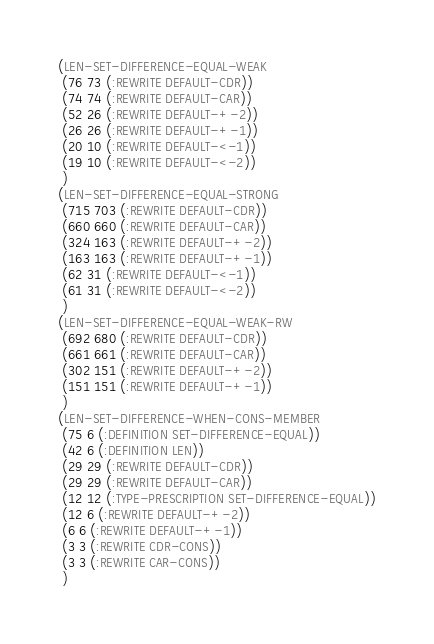<code> <loc_0><loc_0><loc_500><loc_500><_Lisp_>(LEN-SET-DIFFERENCE-EQUAL-WEAK
 (76 73 (:REWRITE DEFAULT-CDR))
 (74 74 (:REWRITE DEFAULT-CAR))
 (52 26 (:REWRITE DEFAULT-+-2))
 (26 26 (:REWRITE DEFAULT-+-1))
 (20 10 (:REWRITE DEFAULT-<-1))
 (19 10 (:REWRITE DEFAULT-<-2))
 )
(LEN-SET-DIFFERENCE-EQUAL-STRONG
 (715 703 (:REWRITE DEFAULT-CDR))
 (660 660 (:REWRITE DEFAULT-CAR))
 (324 163 (:REWRITE DEFAULT-+-2))
 (163 163 (:REWRITE DEFAULT-+-1))
 (62 31 (:REWRITE DEFAULT-<-1))
 (61 31 (:REWRITE DEFAULT-<-2))
 )
(LEN-SET-DIFFERENCE-EQUAL-WEAK-RW
 (692 680 (:REWRITE DEFAULT-CDR))
 (661 661 (:REWRITE DEFAULT-CAR))
 (302 151 (:REWRITE DEFAULT-+-2))
 (151 151 (:REWRITE DEFAULT-+-1))
 )
(LEN-SET-DIFFERENCE-WHEN-CONS-MEMBER
 (75 6 (:DEFINITION SET-DIFFERENCE-EQUAL))
 (42 6 (:DEFINITION LEN))
 (29 29 (:REWRITE DEFAULT-CDR))
 (29 29 (:REWRITE DEFAULT-CAR))
 (12 12 (:TYPE-PRESCRIPTION SET-DIFFERENCE-EQUAL))
 (12 6 (:REWRITE DEFAULT-+-2))
 (6 6 (:REWRITE DEFAULT-+-1))
 (3 3 (:REWRITE CDR-CONS))
 (3 3 (:REWRITE CAR-CONS))
 )</code> 